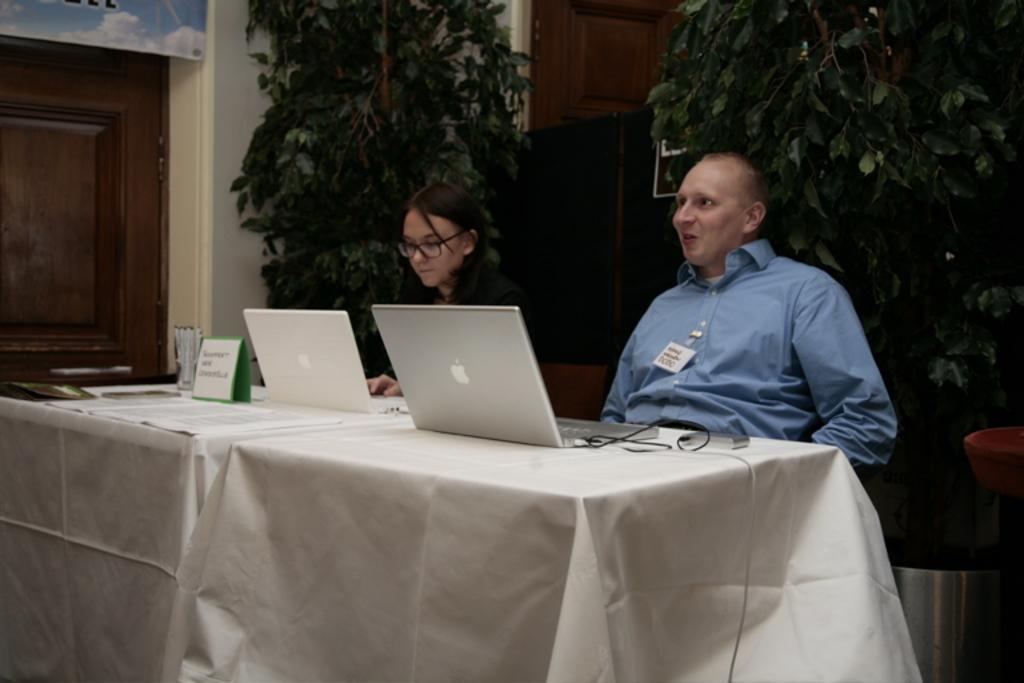How would you summarize this image in a sentence or two? There are two members sitting in a chairs in front of a table on which laptop were placed. There is a man and a woman in this picture. In the background there are some trees and a wall here. We can observe a door in left side. 